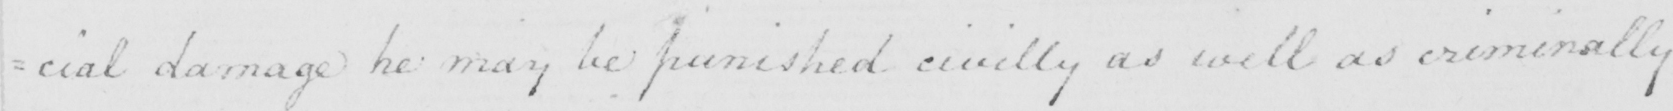What does this handwritten line say? =cial damage he may be punished civilly as well as criminally 